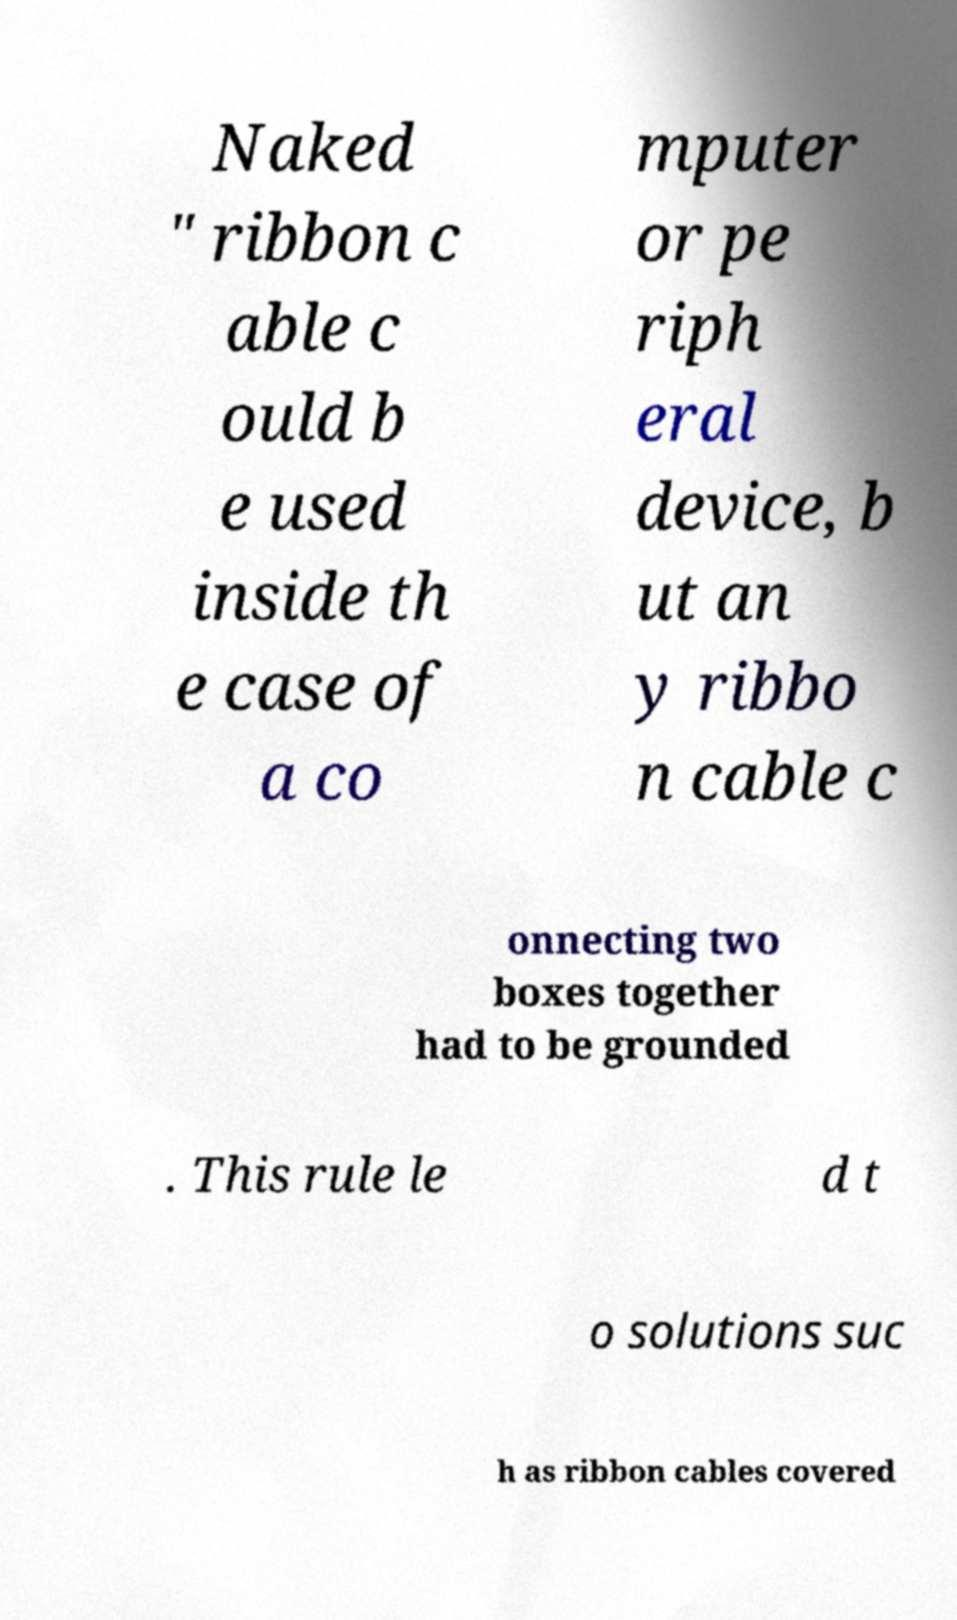I need the written content from this picture converted into text. Can you do that? Naked " ribbon c able c ould b e used inside th e case of a co mputer or pe riph eral device, b ut an y ribbo n cable c onnecting two boxes together had to be grounded . This rule le d t o solutions suc h as ribbon cables covered 